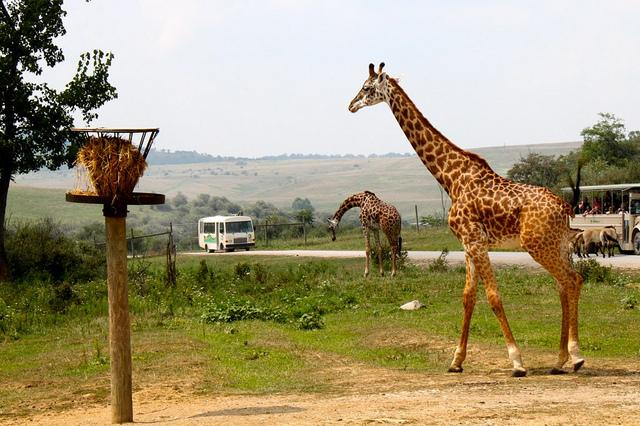What are the people on the vehicle to the right involved in? safari 